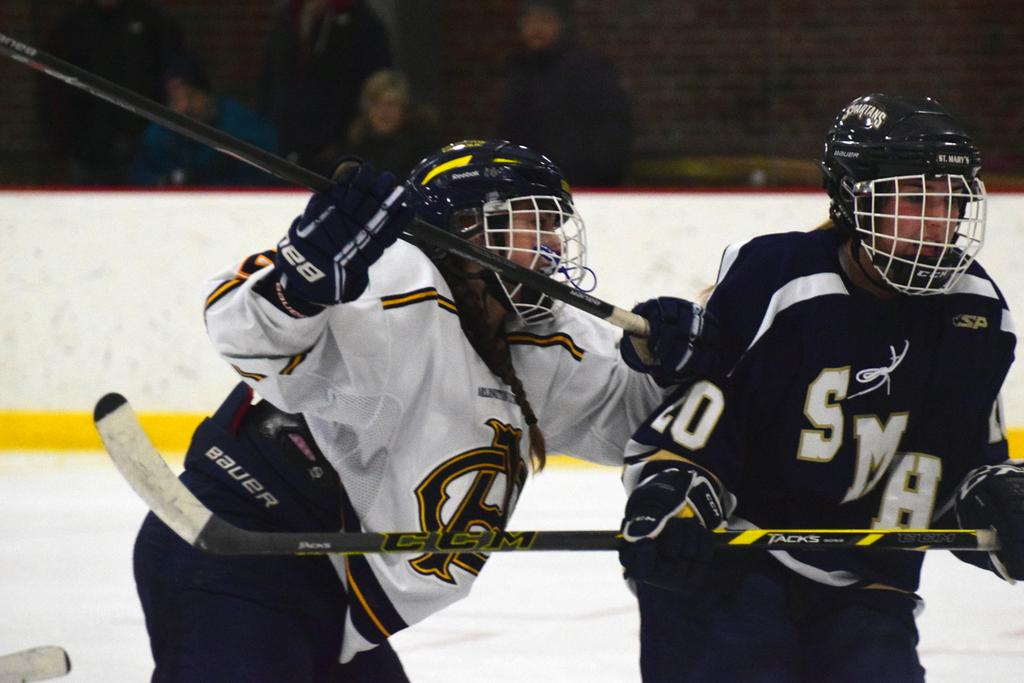How many people are in the image? There are two persons in the image. What are the persons holding in the image? The persons are holding hockey sticks. What can be seen in the background of the image? There is a fence and people sitting in the background of the image. What are the people in the background doing? The people in the background are watching a game. Can you see a boat in the image? No, there is no boat present in the image. What type of expansion is happening in the image? There is no expansion mentioned or depicted in the image. 